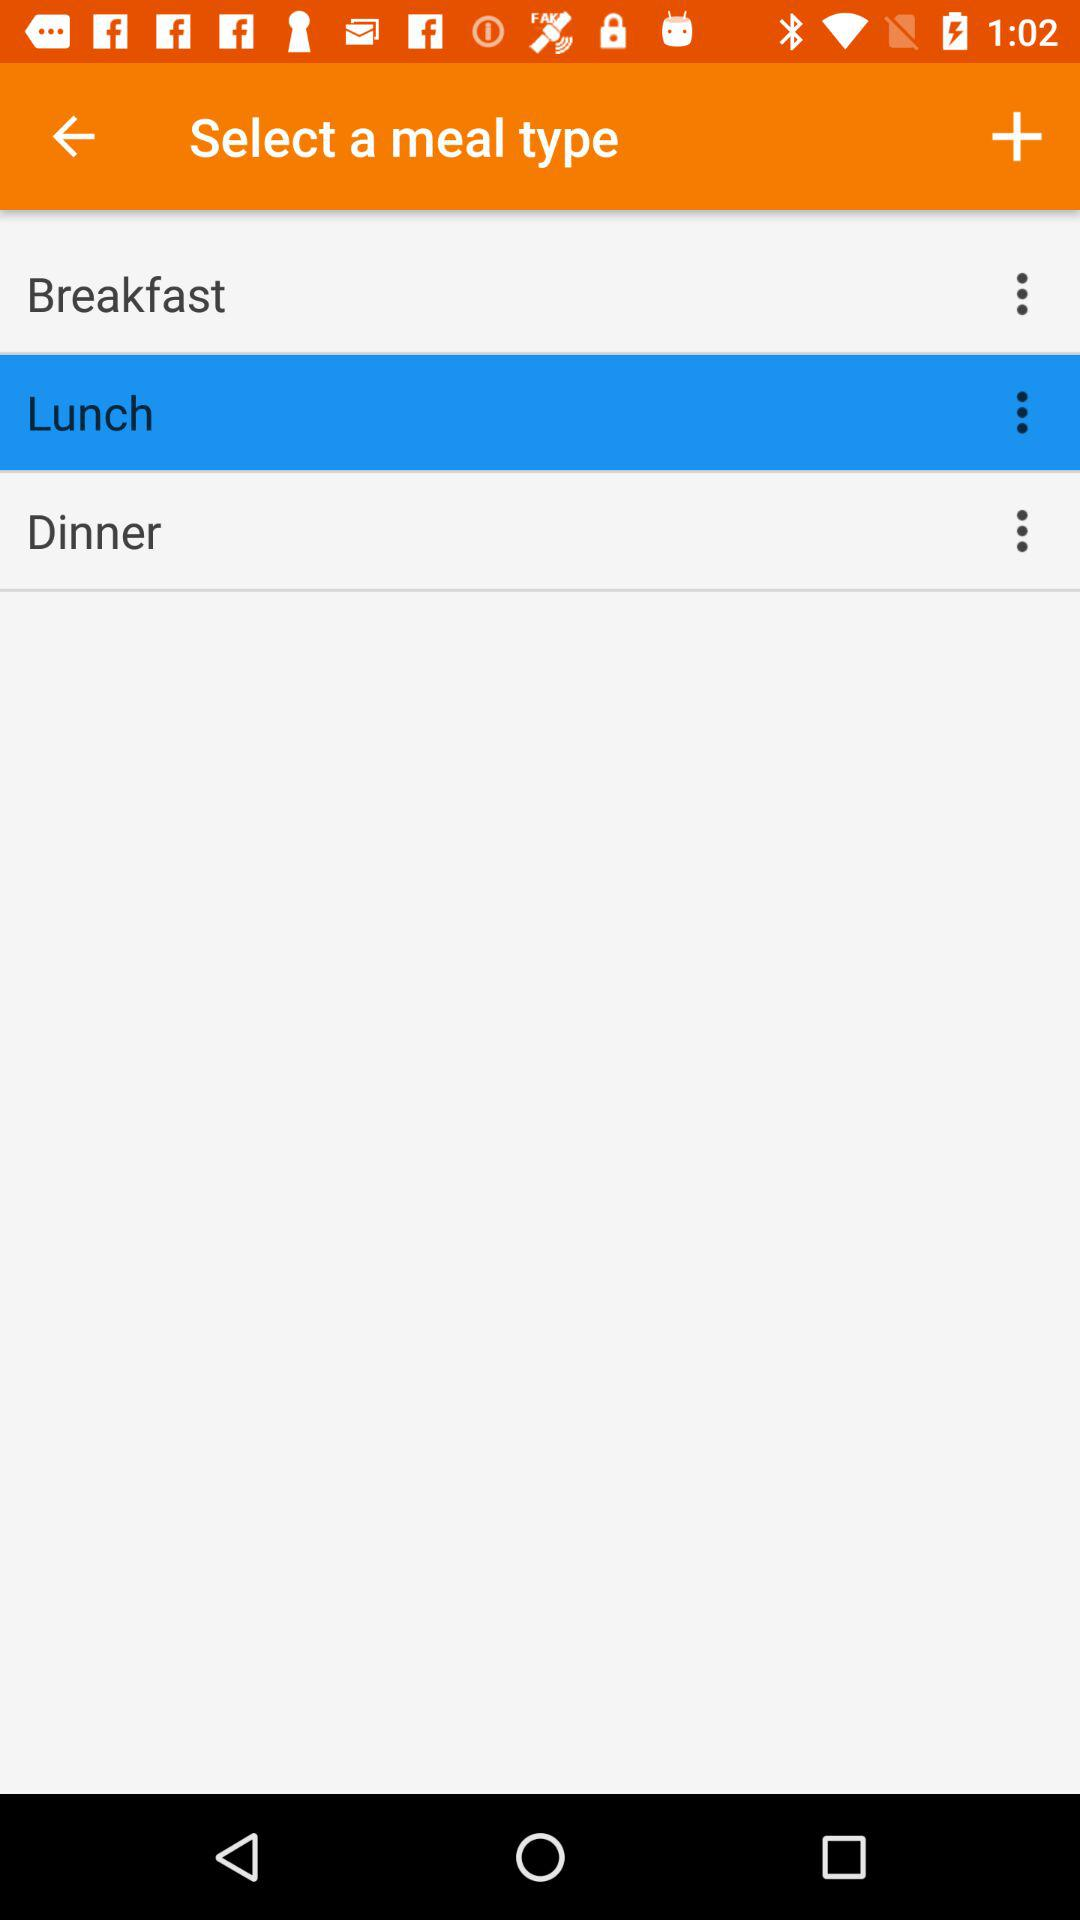How many meal types are there?
Answer the question using a single word or phrase. 3 